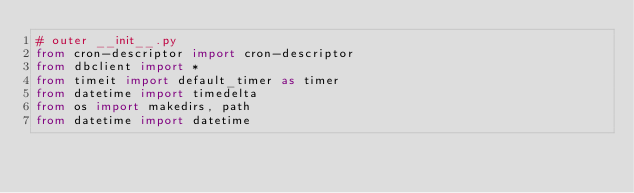Convert code to text. <code><loc_0><loc_0><loc_500><loc_500><_Python_># outer __init__.py
from cron-descriptor import cron-descriptor
from dbclient import *
from timeit import default_timer as timer
from datetime import timedelta
from os import makedirs, path
from datetime import datetime
</code> 